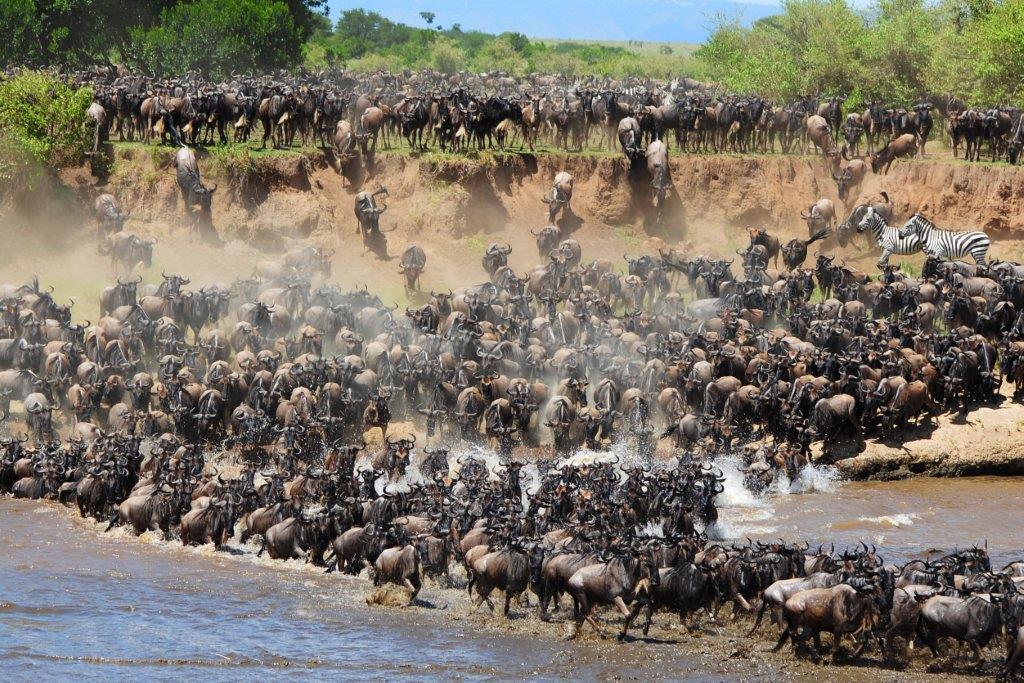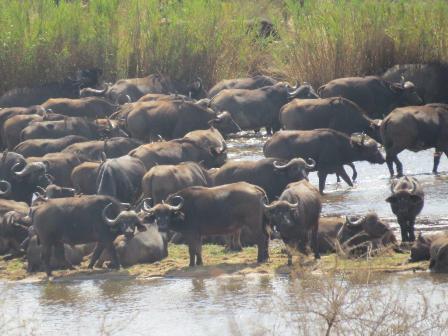The first image is the image on the left, the second image is the image on the right. Given the left and right images, does the statement "Several water buffalos are standing in water in one of the images." hold true? Answer yes or no. Yes. The first image is the image on the left, the second image is the image on the right. For the images shown, is this caption "The left image shows a fog-like cloud above a herd of dark hooved animals moving en masse." true? Answer yes or no. Yes. 